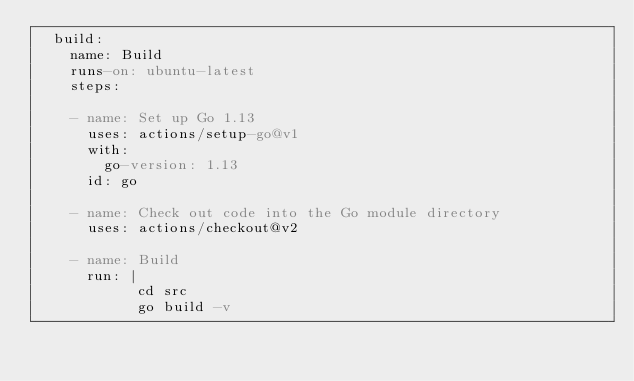Convert code to text. <code><loc_0><loc_0><loc_500><loc_500><_YAML_>  build:
    name: Build
    runs-on: ubuntu-latest
    steps:

    - name: Set up Go 1.13
      uses: actions/setup-go@v1
      with:
        go-version: 1.13
      id: go

    - name: Check out code into the Go module directory
      uses: actions/checkout@v2

    - name: Build
      run: |
            cd src
            go build -v
</code> 